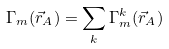<formula> <loc_0><loc_0><loc_500><loc_500>\Gamma _ { m } ( \vec { r } _ { A } ) = \sum _ { k } \Gamma _ { m } ^ { k } ( \vec { r } _ { A } )</formula> 